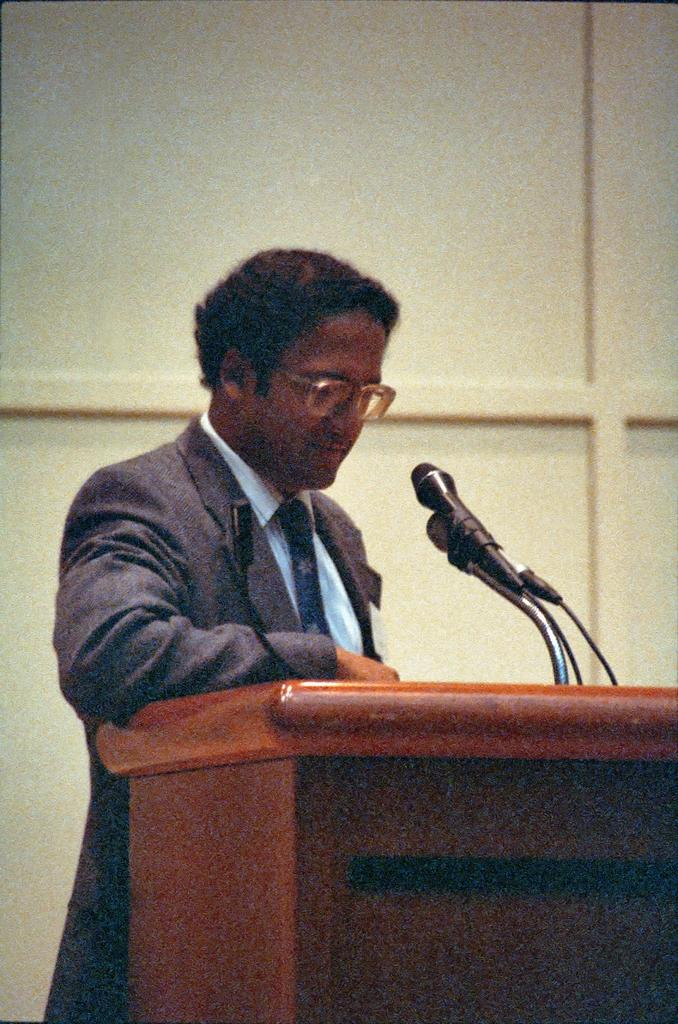What is the person in the image doing? The person is standing in front of the podium. What is on the podium? The podium has microphones on it. What can be seen in the background of the image? There is a wall in the background of the image. How many ants are crawling on the microphones in the image? There are no ants present in the image. 